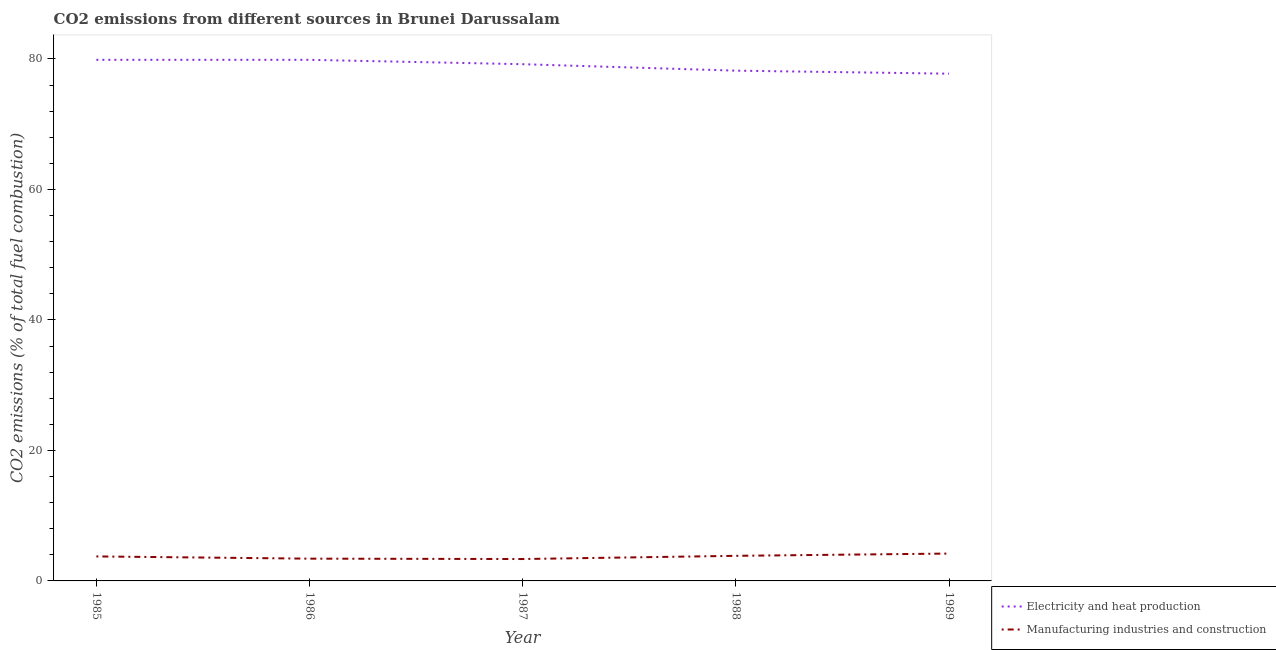What is the co2 emissions due to electricity and heat production in 1986?
Give a very brief answer. 79.86. Across all years, what is the maximum co2 emissions due to electricity and heat production?
Your response must be concise. 79.86. Across all years, what is the minimum co2 emissions due to manufacturing industries?
Your answer should be very brief. 3.36. In which year was the co2 emissions due to electricity and heat production minimum?
Give a very brief answer. 1989. What is the total co2 emissions due to manufacturing industries in the graph?
Offer a terse response. 18.56. What is the difference between the co2 emissions due to electricity and heat production in 1985 and that in 1988?
Ensure brevity in your answer.  1.66. What is the difference between the co2 emissions due to electricity and heat production in 1989 and the co2 emissions due to manufacturing industries in 1988?
Make the answer very short. 73.9. What is the average co2 emissions due to electricity and heat production per year?
Give a very brief answer. 78.97. In the year 1988, what is the difference between the co2 emissions due to electricity and heat production and co2 emissions due to manufacturing industries?
Keep it short and to the point. 74.36. What is the ratio of the co2 emissions due to manufacturing industries in 1985 to that in 1988?
Your answer should be very brief. 0.98. Is the co2 emissions due to electricity and heat production in 1985 less than that in 1988?
Give a very brief answer. No. What is the difference between the highest and the second highest co2 emissions due to electricity and heat production?
Keep it short and to the point. 0. What is the difference between the highest and the lowest co2 emissions due to manufacturing industries?
Give a very brief answer. 0.84. In how many years, is the co2 emissions due to manufacturing industries greater than the average co2 emissions due to manufacturing industries taken over all years?
Provide a short and direct response. 3. Is the sum of the co2 emissions due to manufacturing industries in 1987 and 1989 greater than the maximum co2 emissions due to electricity and heat production across all years?
Your answer should be compact. No. Does the co2 emissions due to manufacturing industries monotonically increase over the years?
Provide a succinct answer. No. Is the co2 emissions due to electricity and heat production strictly greater than the co2 emissions due to manufacturing industries over the years?
Make the answer very short. Yes. How many lines are there?
Offer a very short reply. 2. What is the difference between two consecutive major ticks on the Y-axis?
Keep it short and to the point. 20. Does the graph contain grids?
Make the answer very short. No. Where does the legend appear in the graph?
Your answer should be compact. Bottom right. How many legend labels are there?
Your response must be concise. 2. What is the title of the graph?
Your response must be concise. CO2 emissions from different sources in Brunei Darussalam. What is the label or title of the Y-axis?
Make the answer very short. CO2 emissions (% of total fuel combustion). What is the CO2 emissions (% of total fuel combustion) of Electricity and heat production in 1985?
Give a very brief answer. 79.86. What is the CO2 emissions (% of total fuel combustion) of Manufacturing industries and construction in 1985?
Your response must be concise. 3.75. What is the CO2 emissions (% of total fuel combustion) of Electricity and heat production in 1986?
Offer a very short reply. 79.86. What is the CO2 emissions (% of total fuel combustion) of Manufacturing industries and construction in 1986?
Ensure brevity in your answer.  3.41. What is the CO2 emissions (% of total fuel combustion) of Electricity and heat production in 1987?
Keep it short and to the point. 79.19. What is the CO2 emissions (% of total fuel combustion) of Manufacturing industries and construction in 1987?
Your response must be concise. 3.36. What is the CO2 emissions (% of total fuel combustion) in Electricity and heat production in 1988?
Keep it short and to the point. 78.21. What is the CO2 emissions (% of total fuel combustion) of Manufacturing industries and construction in 1988?
Your response must be concise. 3.85. What is the CO2 emissions (% of total fuel combustion) in Electricity and heat production in 1989?
Give a very brief answer. 77.74. What is the CO2 emissions (% of total fuel combustion) in Manufacturing industries and construction in 1989?
Your answer should be very brief. 4.19. Across all years, what is the maximum CO2 emissions (% of total fuel combustion) of Electricity and heat production?
Ensure brevity in your answer.  79.86. Across all years, what is the maximum CO2 emissions (% of total fuel combustion) of Manufacturing industries and construction?
Your answer should be very brief. 4.19. Across all years, what is the minimum CO2 emissions (% of total fuel combustion) of Electricity and heat production?
Your response must be concise. 77.74. Across all years, what is the minimum CO2 emissions (% of total fuel combustion) in Manufacturing industries and construction?
Your response must be concise. 3.36. What is the total CO2 emissions (% of total fuel combustion) of Electricity and heat production in the graph?
Your response must be concise. 394.87. What is the total CO2 emissions (% of total fuel combustion) of Manufacturing industries and construction in the graph?
Provide a succinct answer. 18.56. What is the difference between the CO2 emissions (% of total fuel combustion) in Electricity and heat production in 1985 and that in 1986?
Keep it short and to the point. 0. What is the difference between the CO2 emissions (% of total fuel combustion) in Manufacturing industries and construction in 1985 and that in 1986?
Offer a very short reply. 0.34. What is the difference between the CO2 emissions (% of total fuel combustion) in Electricity and heat production in 1985 and that in 1987?
Offer a terse response. 0.67. What is the difference between the CO2 emissions (% of total fuel combustion) in Manufacturing industries and construction in 1985 and that in 1987?
Give a very brief answer. 0.4. What is the difference between the CO2 emissions (% of total fuel combustion) in Electricity and heat production in 1985 and that in 1988?
Ensure brevity in your answer.  1.66. What is the difference between the CO2 emissions (% of total fuel combustion) in Manufacturing industries and construction in 1985 and that in 1988?
Your response must be concise. -0.09. What is the difference between the CO2 emissions (% of total fuel combustion) of Electricity and heat production in 1985 and that in 1989?
Offer a very short reply. 2.12. What is the difference between the CO2 emissions (% of total fuel combustion) of Manufacturing industries and construction in 1985 and that in 1989?
Your answer should be compact. -0.44. What is the difference between the CO2 emissions (% of total fuel combustion) of Electricity and heat production in 1986 and that in 1987?
Provide a succinct answer. 0.67. What is the difference between the CO2 emissions (% of total fuel combustion) in Manufacturing industries and construction in 1986 and that in 1987?
Offer a very short reply. 0.06. What is the difference between the CO2 emissions (% of total fuel combustion) in Electricity and heat production in 1986 and that in 1988?
Make the answer very short. 1.66. What is the difference between the CO2 emissions (% of total fuel combustion) in Manufacturing industries and construction in 1986 and that in 1988?
Keep it short and to the point. -0.43. What is the difference between the CO2 emissions (% of total fuel combustion) in Electricity and heat production in 1986 and that in 1989?
Keep it short and to the point. 2.12. What is the difference between the CO2 emissions (% of total fuel combustion) in Manufacturing industries and construction in 1986 and that in 1989?
Your answer should be compact. -0.78. What is the difference between the CO2 emissions (% of total fuel combustion) of Manufacturing industries and construction in 1987 and that in 1988?
Give a very brief answer. -0.49. What is the difference between the CO2 emissions (% of total fuel combustion) of Electricity and heat production in 1987 and that in 1989?
Provide a short and direct response. 1.45. What is the difference between the CO2 emissions (% of total fuel combustion) of Manufacturing industries and construction in 1987 and that in 1989?
Offer a very short reply. -0.84. What is the difference between the CO2 emissions (% of total fuel combustion) in Electricity and heat production in 1988 and that in 1989?
Give a very brief answer. 0.46. What is the difference between the CO2 emissions (% of total fuel combustion) of Manufacturing industries and construction in 1988 and that in 1989?
Provide a succinct answer. -0.35. What is the difference between the CO2 emissions (% of total fuel combustion) of Electricity and heat production in 1985 and the CO2 emissions (% of total fuel combustion) of Manufacturing industries and construction in 1986?
Make the answer very short. 76.45. What is the difference between the CO2 emissions (% of total fuel combustion) of Electricity and heat production in 1985 and the CO2 emissions (% of total fuel combustion) of Manufacturing industries and construction in 1987?
Your response must be concise. 76.51. What is the difference between the CO2 emissions (% of total fuel combustion) in Electricity and heat production in 1985 and the CO2 emissions (% of total fuel combustion) in Manufacturing industries and construction in 1988?
Your answer should be very brief. 76.02. What is the difference between the CO2 emissions (% of total fuel combustion) in Electricity and heat production in 1985 and the CO2 emissions (% of total fuel combustion) in Manufacturing industries and construction in 1989?
Your answer should be compact. 75.67. What is the difference between the CO2 emissions (% of total fuel combustion) in Electricity and heat production in 1986 and the CO2 emissions (% of total fuel combustion) in Manufacturing industries and construction in 1987?
Your response must be concise. 76.51. What is the difference between the CO2 emissions (% of total fuel combustion) in Electricity and heat production in 1986 and the CO2 emissions (% of total fuel combustion) in Manufacturing industries and construction in 1988?
Offer a very short reply. 76.02. What is the difference between the CO2 emissions (% of total fuel combustion) of Electricity and heat production in 1986 and the CO2 emissions (% of total fuel combustion) of Manufacturing industries and construction in 1989?
Offer a very short reply. 75.67. What is the difference between the CO2 emissions (% of total fuel combustion) of Electricity and heat production in 1987 and the CO2 emissions (% of total fuel combustion) of Manufacturing industries and construction in 1988?
Make the answer very short. 75.35. What is the difference between the CO2 emissions (% of total fuel combustion) of Electricity and heat production in 1987 and the CO2 emissions (% of total fuel combustion) of Manufacturing industries and construction in 1989?
Offer a terse response. 75. What is the difference between the CO2 emissions (% of total fuel combustion) of Electricity and heat production in 1988 and the CO2 emissions (% of total fuel combustion) of Manufacturing industries and construction in 1989?
Provide a short and direct response. 74.01. What is the average CO2 emissions (% of total fuel combustion) in Electricity and heat production per year?
Give a very brief answer. 78.97. What is the average CO2 emissions (% of total fuel combustion) in Manufacturing industries and construction per year?
Your answer should be compact. 3.71. In the year 1985, what is the difference between the CO2 emissions (% of total fuel combustion) of Electricity and heat production and CO2 emissions (% of total fuel combustion) of Manufacturing industries and construction?
Keep it short and to the point. 76.11. In the year 1986, what is the difference between the CO2 emissions (% of total fuel combustion) in Electricity and heat production and CO2 emissions (% of total fuel combustion) in Manufacturing industries and construction?
Your answer should be very brief. 76.45. In the year 1987, what is the difference between the CO2 emissions (% of total fuel combustion) of Electricity and heat production and CO2 emissions (% of total fuel combustion) of Manufacturing industries and construction?
Give a very brief answer. 75.84. In the year 1988, what is the difference between the CO2 emissions (% of total fuel combustion) in Electricity and heat production and CO2 emissions (% of total fuel combustion) in Manufacturing industries and construction?
Give a very brief answer. 74.36. In the year 1989, what is the difference between the CO2 emissions (% of total fuel combustion) in Electricity and heat production and CO2 emissions (% of total fuel combustion) in Manufacturing industries and construction?
Offer a terse response. 73.55. What is the ratio of the CO2 emissions (% of total fuel combustion) of Electricity and heat production in 1985 to that in 1986?
Make the answer very short. 1. What is the ratio of the CO2 emissions (% of total fuel combustion) of Manufacturing industries and construction in 1985 to that in 1986?
Keep it short and to the point. 1.1. What is the ratio of the CO2 emissions (% of total fuel combustion) in Electricity and heat production in 1985 to that in 1987?
Ensure brevity in your answer.  1.01. What is the ratio of the CO2 emissions (% of total fuel combustion) of Manufacturing industries and construction in 1985 to that in 1987?
Your response must be concise. 1.12. What is the ratio of the CO2 emissions (% of total fuel combustion) of Electricity and heat production in 1985 to that in 1988?
Your answer should be compact. 1.02. What is the ratio of the CO2 emissions (% of total fuel combustion) of Manufacturing industries and construction in 1985 to that in 1988?
Keep it short and to the point. 0.98. What is the ratio of the CO2 emissions (% of total fuel combustion) in Electricity and heat production in 1985 to that in 1989?
Offer a very short reply. 1.03. What is the ratio of the CO2 emissions (% of total fuel combustion) of Manufacturing industries and construction in 1985 to that in 1989?
Your response must be concise. 0.9. What is the ratio of the CO2 emissions (% of total fuel combustion) of Electricity and heat production in 1986 to that in 1987?
Your answer should be compact. 1.01. What is the ratio of the CO2 emissions (% of total fuel combustion) in Manufacturing industries and construction in 1986 to that in 1987?
Provide a succinct answer. 1.02. What is the ratio of the CO2 emissions (% of total fuel combustion) of Electricity and heat production in 1986 to that in 1988?
Your response must be concise. 1.02. What is the ratio of the CO2 emissions (% of total fuel combustion) of Manufacturing industries and construction in 1986 to that in 1988?
Provide a short and direct response. 0.89. What is the ratio of the CO2 emissions (% of total fuel combustion) of Electricity and heat production in 1986 to that in 1989?
Ensure brevity in your answer.  1.03. What is the ratio of the CO2 emissions (% of total fuel combustion) in Manufacturing industries and construction in 1986 to that in 1989?
Ensure brevity in your answer.  0.81. What is the ratio of the CO2 emissions (% of total fuel combustion) of Electricity and heat production in 1987 to that in 1988?
Give a very brief answer. 1.01. What is the ratio of the CO2 emissions (% of total fuel combustion) of Manufacturing industries and construction in 1987 to that in 1988?
Your answer should be very brief. 0.87. What is the ratio of the CO2 emissions (% of total fuel combustion) in Electricity and heat production in 1987 to that in 1989?
Provide a succinct answer. 1.02. What is the ratio of the CO2 emissions (% of total fuel combustion) of Manufacturing industries and construction in 1987 to that in 1989?
Make the answer very short. 0.8. What is the ratio of the CO2 emissions (% of total fuel combustion) of Manufacturing industries and construction in 1988 to that in 1989?
Ensure brevity in your answer.  0.92. What is the difference between the highest and the second highest CO2 emissions (% of total fuel combustion) in Manufacturing industries and construction?
Ensure brevity in your answer.  0.35. What is the difference between the highest and the lowest CO2 emissions (% of total fuel combustion) in Electricity and heat production?
Make the answer very short. 2.12. What is the difference between the highest and the lowest CO2 emissions (% of total fuel combustion) of Manufacturing industries and construction?
Provide a short and direct response. 0.84. 